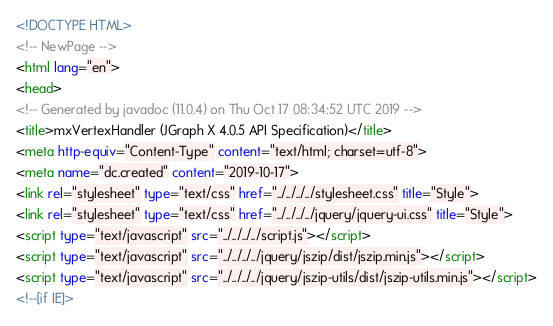<code> <loc_0><loc_0><loc_500><loc_500><_HTML_><!DOCTYPE HTML>
<!-- NewPage -->
<html lang="en">
<head>
<!-- Generated by javadoc (11.0.4) on Thu Oct 17 08:34:52 UTC 2019 -->
<title>mxVertexHandler (JGraph X 4.0.5 API Specification)</title>
<meta http-equiv="Content-Type" content="text/html; charset=utf-8">
<meta name="dc.created" content="2019-10-17">
<link rel="stylesheet" type="text/css" href="../../../../stylesheet.css" title="Style">
<link rel="stylesheet" type="text/css" href="../../../../jquery/jquery-ui.css" title="Style">
<script type="text/javascript" src="../../../../script.js"></script>
<script type="text/javascript" src="../../../../jquery/jszip/dist/jszip.min.js"></script>
<script type="text/javascript" src="../../../../jquery/jszip-utils/dist/jszip-utils.min.js"></script>
<!--[if IE]></code> 